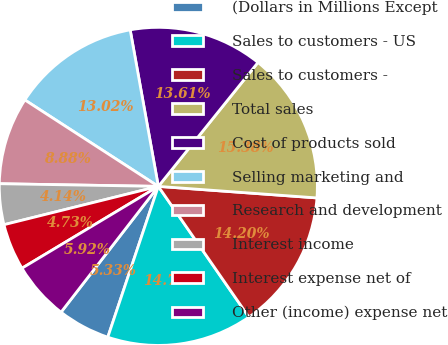<chart> <loc_0><loc_0><loc_500><loc_500><pie_chart><fcel>(Dollars in Millions Except<fcel>Sales to customers - US<fcel>Sales to customers -<fcel>Total sales<fcel>Cost of products sold<fcel>Selling marketing and<fcel>Research and development<fcel>Interest income<fcel>Interest expense net of<fcel>Other (income) expense net<nl><fcel>5.33%<fcel>14.79%<fcel>14.2%<fcel>15.38%<fcel>13.61%<fcel>13.02%<fcel>8.88%<fcel>4.14%<fcel>4.73%<fcel>5.92%<nl></chart> 